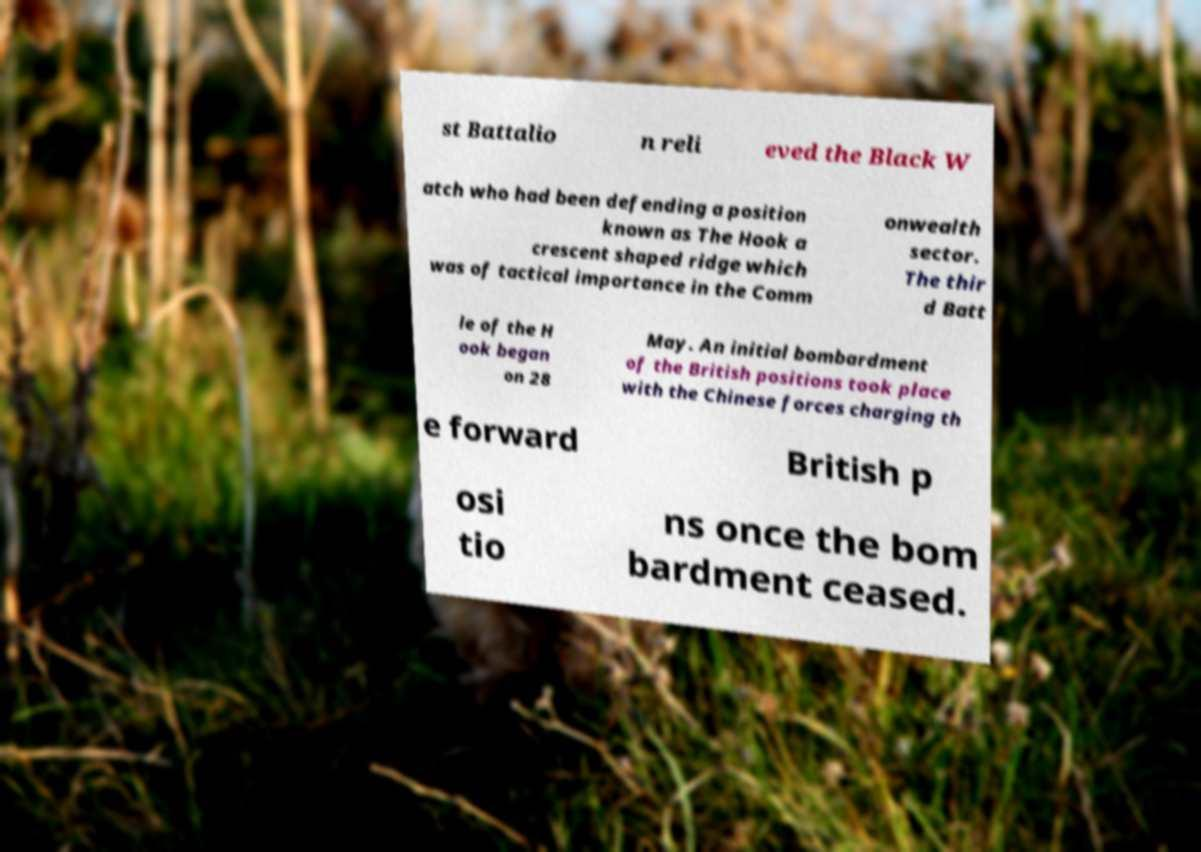Can you read and provide the text displayed in the image?This photo seems to have some interesting text. Can you extract and type it out for me? st Battalio n reli eved the Black W atch who had been defending a position known as The Hook a crescent shaped ridge which was of tactical importance in the Comm onwealth sector. The thir d Batt le of the H ook began on 28 May. An initial bombardment of the British positions took place with the Chinese forces charging th e forward British p osi tio ns once the bom bardment ceased. 